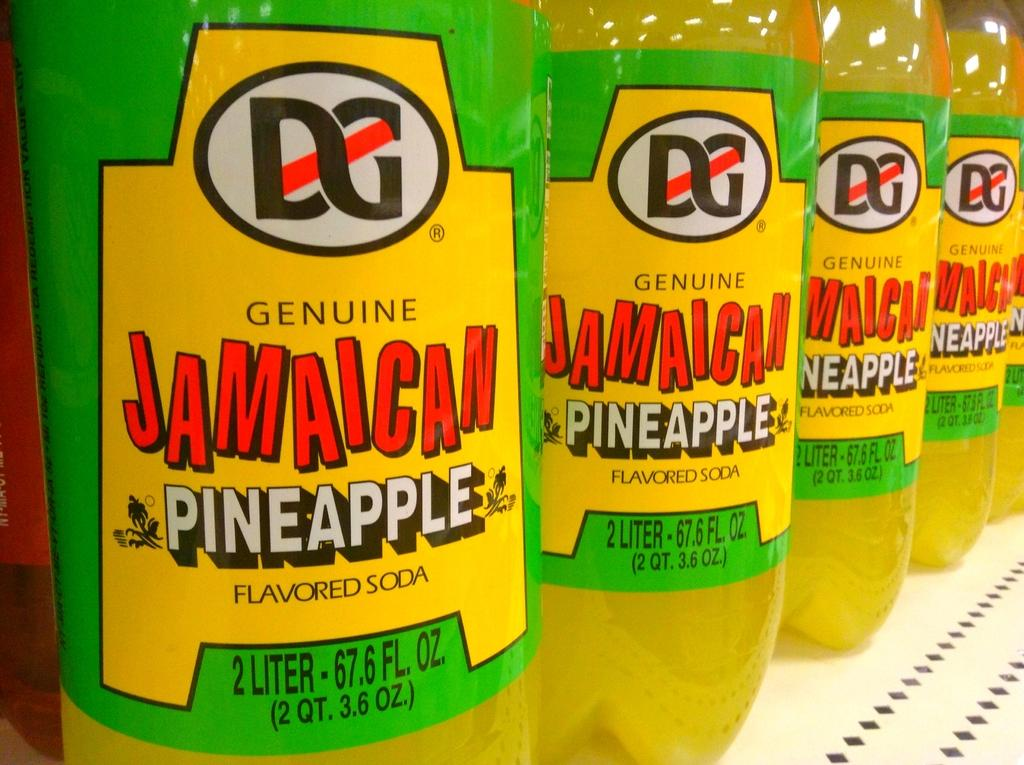<image>
Present a compact description of the photo's key features. Genuine Jamaican pineapple flavored soda comes in a 2 liter. 